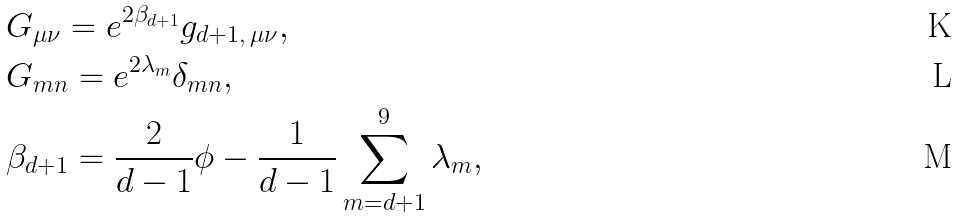Convert formula to latex. <formula><loc_0><loc_0><loc_500><loc_500>& G _ { \mu \nu } = e ^ { 2 \beta _ { d + 1 } } g _ { d + 1 , \, \mu \nu } , \\ & G _ { m n } = e ^ { 2 \lambda _ { m } } \delta _ { m n } , \\ & \beta _ { d + 1 } = \frac { 2 } { d - 1 } \phi - \frac { 1 } { d - 1 } \sum _ { m = d + 1 } ^ { 9 } \lambda _ { m } ,</formula> 